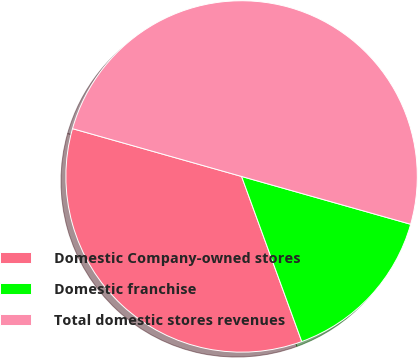<chart> <loc_0><loc_0><loc_500><loc_500><pie_chart><fcel>Domestic Company-owned stores<fcel>Domestic franchise<fcel>Total domestic stores revenues<nl><fcel>34.95%<fcel>15.05%<fcel>50.0%<nl></chart> 